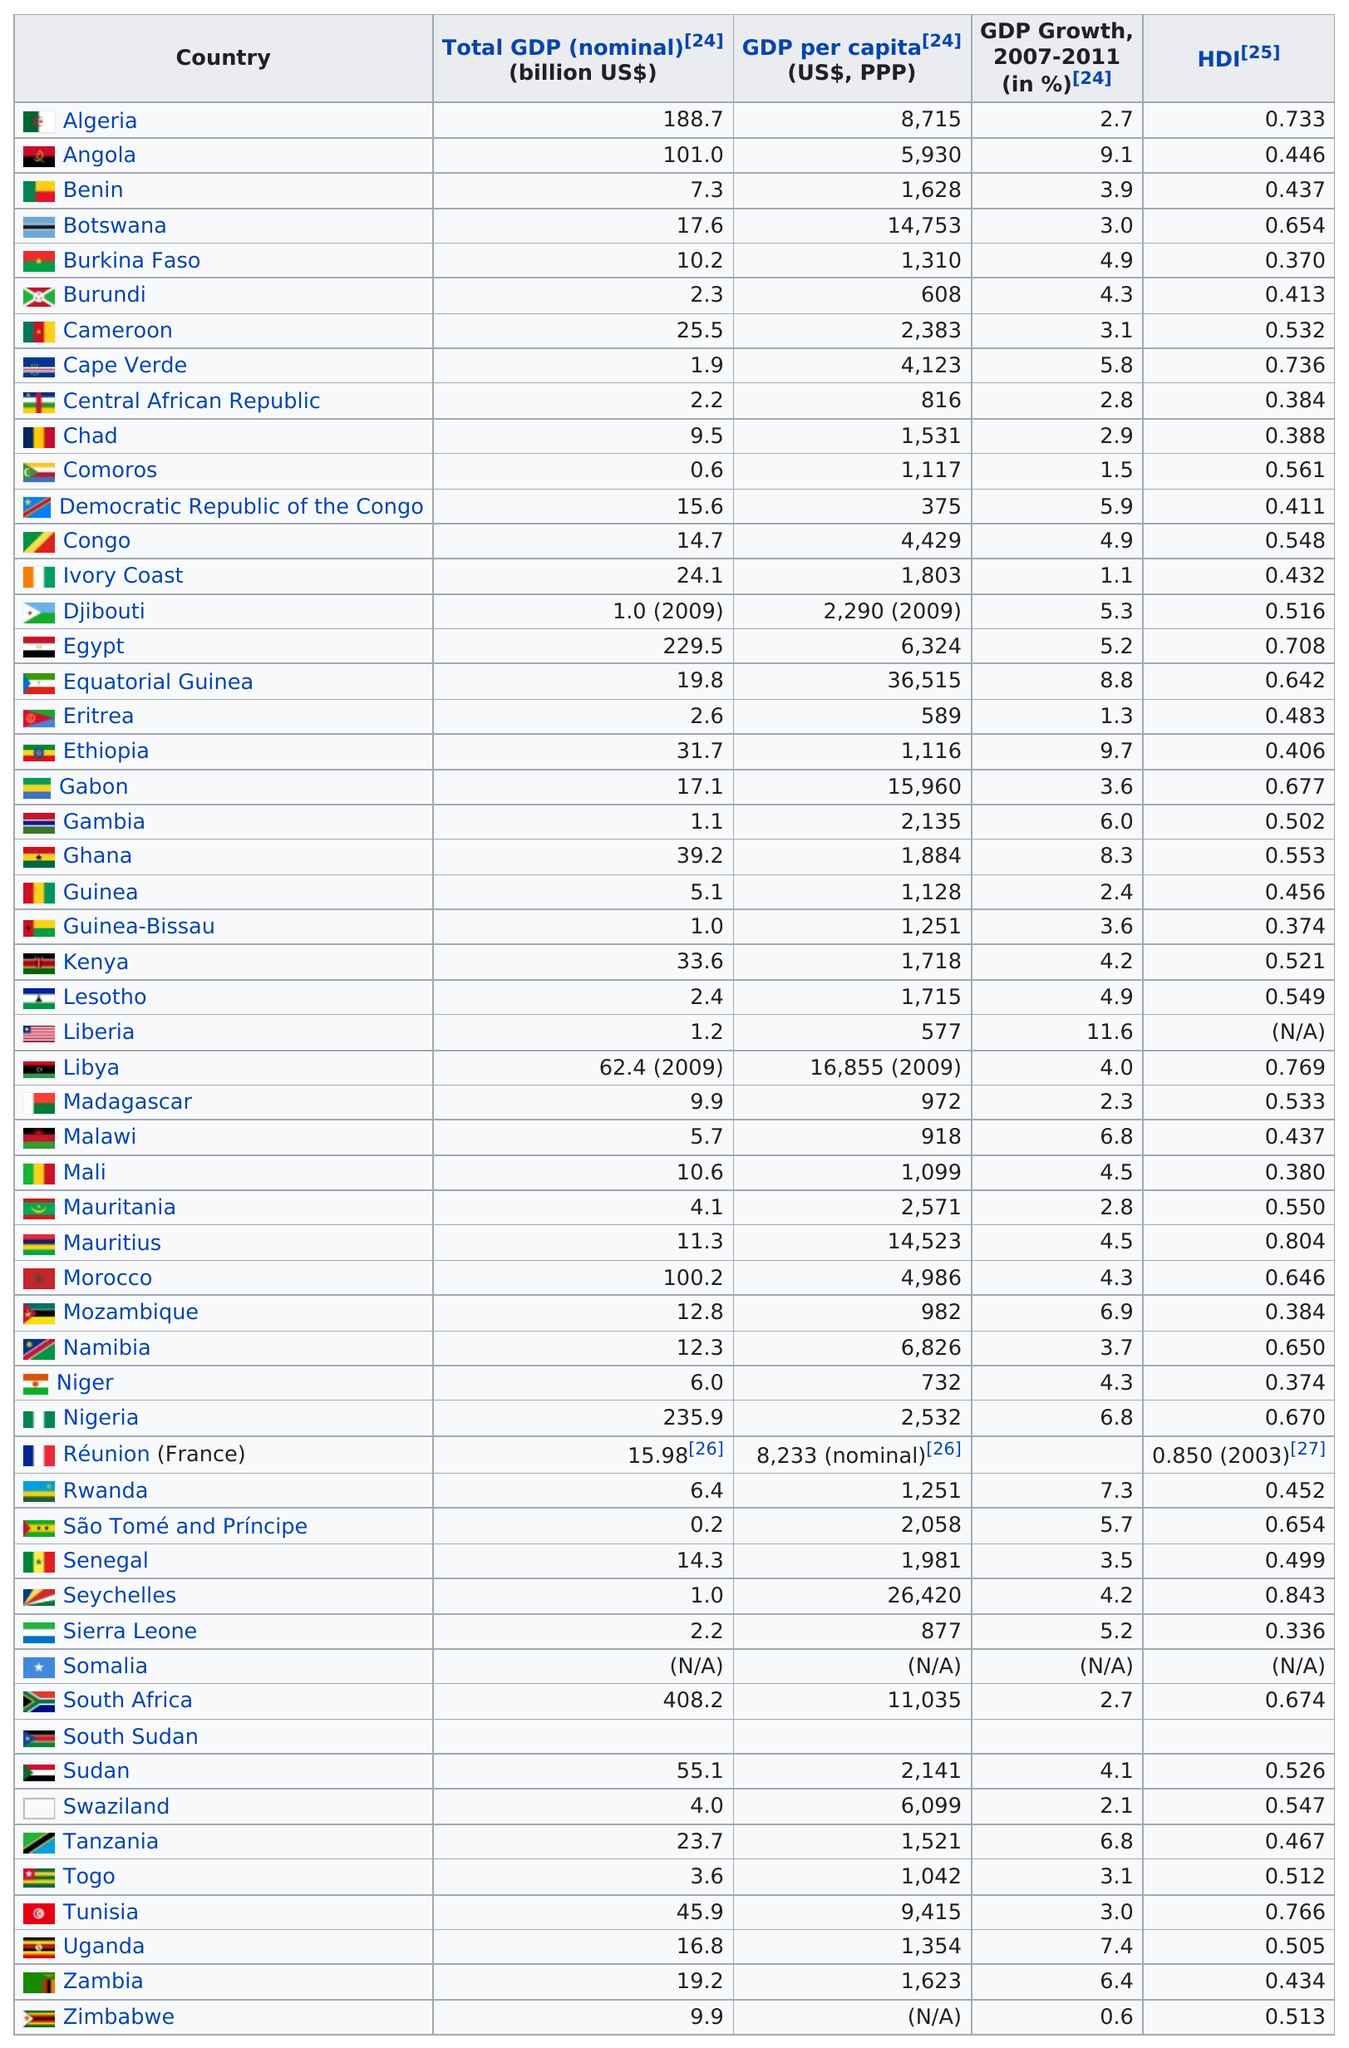Specify some key components in this picture. South Africa is the country with the highest total GDP among all countries. Out of the countries that have a total GDP of 2.2 billion dollars, there are approximately 2 of them. Angola or Ethiopia, which has the larger GDP growth? The answer is clear: Ethiopia has the larger GDP growth. Ivory Coast is the country with the lowest GDP growth, where GDP nominal is greater than 5 and GDP per capita is less than 5000. Zimbabwe is the only country to have recorded a 0.6% growth in its GDP. 